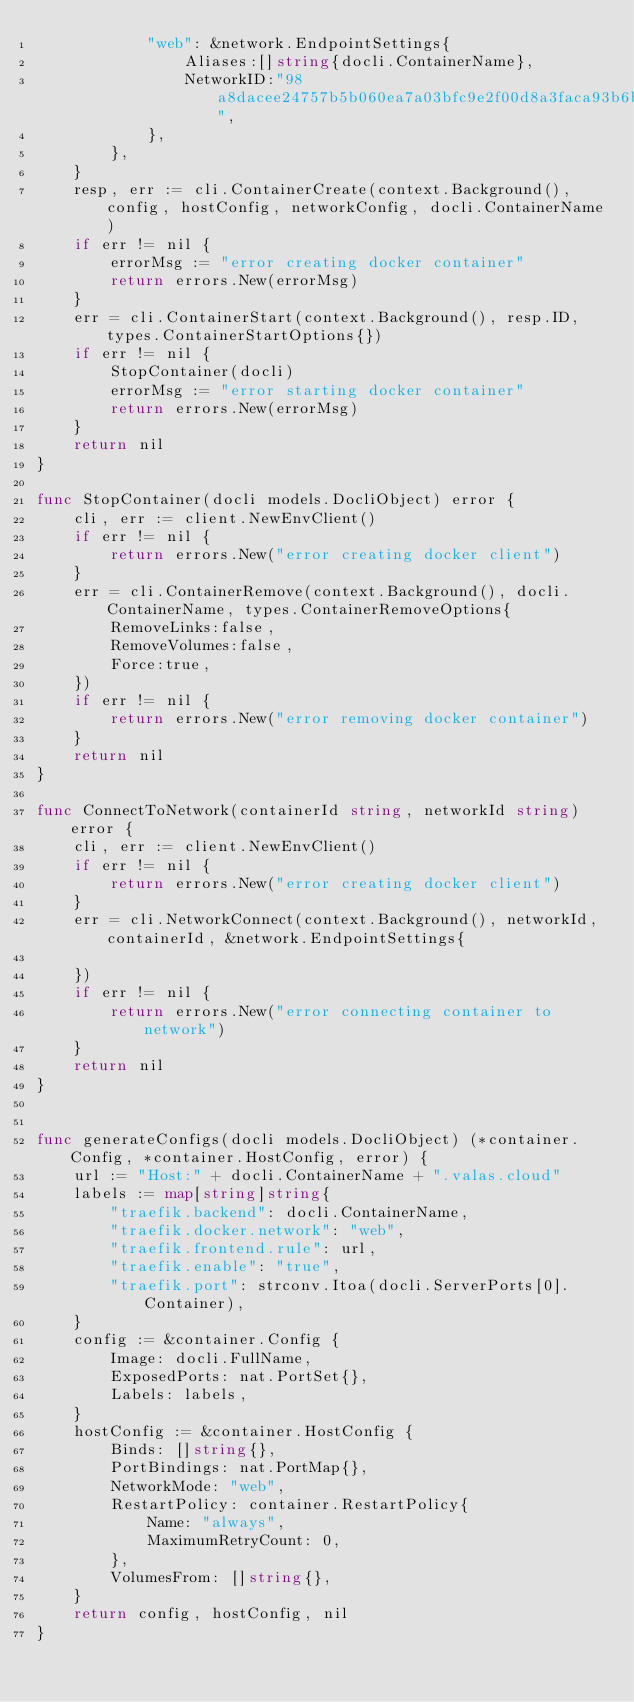<code> <loc_0><loc_0><loc_500><loc_500><_Go_>			"web": &network.EndpointSettings{
				Aliases:[]string{docli.ContainerName},
				NetworkID:"98a8dacee24757b5b060ea7a03bfc9e2f00d8a3faca93b6b39f9034390eb4044",
			},
		},
	}
	resp, err := cli.ContainerCreate(context.Background(), config, hostConfig, networkConfig, docli.ContainerName)
	if err != nil {
		errorMsg := "error creating docker container"
		return errors.New(errorMsg)
	}
	err = cli.ContainerStart(context.Background(), resp.ID, types.ContainerStartOptions{})
	if err != nil {
		StopContainer(docli)
		errorMsg := "error starting docker container"
		return errors.New(errorMsg)
	}
	return nil
}

func StopContainer(docli models.DocliObject) error {
	cli, err := client.NewEnvClient()
	if err != nil {
		return errors.New("error creating docker client")
	}
	err = cli.ContainerRemove(context.Background(), docli.ContainerName, types.ContainerRemoveOptions{
		RemoveLinks:false,
		RemoveVolumes:false,
		Force:true,
	})
	if err != nil {
		return errors.New("error removing docker container")
	}
	return nil
}

func ConnectToNetwork(containerId string, networkId string) error {
	cli, err := client.NewEnvClient()
	if err != nil {
		return errors.New("error creating docker client")
	}
	err = cli.NetworkConnect(context.Background(), networkId, containerId, &network.EndpointSettings{

	})
	if err != nil {
		return errors.New("error connecting container to network")
	}
	return nil
}


func generateConfigs(docli models.DocliObject) (*container.Config, *container.HostConfig, error) {
	url := "Host:" + docli.ContainerName + ".valas.cloud"
	labels := map[string]string{
		"traefik.backend": docli.ContainerName,
		"traefik.docker.network": "web",
		"traefik.frontend.rule": url,
		"traefik.enable": "true",
		"traefik.port": strconv.Itoa(docli.ServerPorts[0].Container),
	}
	config := &container.Config {
		Image: docli.FullName,
		ExposedPorts: nat.PortSet{},
		Labels: labels,
	}
	hostConfig := &container.HostConfig {
		Binds: []string{},
		PortBindings: nat.PortMap{},
		NetworkMode: "web",
		RestartPolicy: container.RestartPolicy{
			Name: "always",
			MaximumRetryCount: 0,
		},
		VolumesFrom: []string{},
	}
	return config, hostConfig, nil
}</code> 